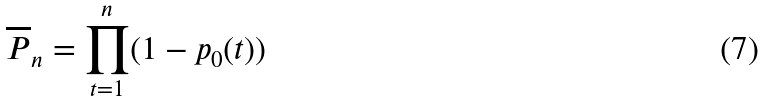<formula> <loc_0><loc_0><loc_500><loc_500>\overline { P } _ { n } = \prod _ { t = 1 } ^ { n } ( 1 - p _ { 0 } ( t ) )</formula> 